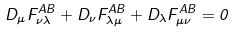Convert formula to latex. <formula><loc_0><loc_0><loc_500><loc_500>D _ { \mu } F _ { \nu \lambda } ^ { A B } + D _ { \nu } F _ { \lambda \mu } ^ { A B } + D _ { \lambda } F _ { \mu \nu } ^ { A B } = 0</formula> 